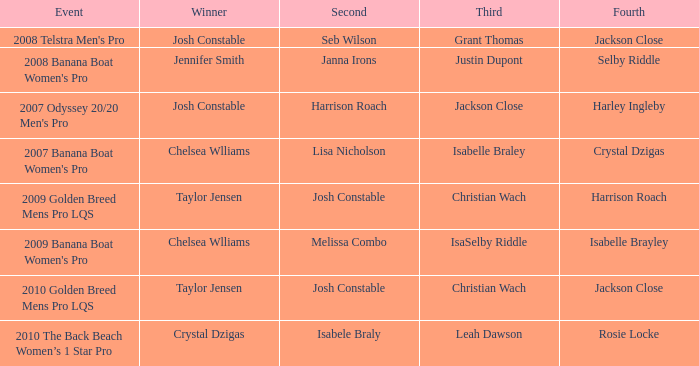Who was Fourth in the 2008 Telstra Men's Pro Event? Jackson Close. 